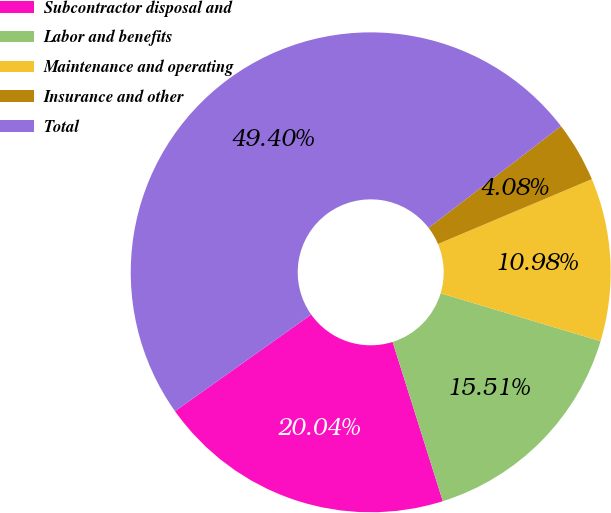Convert chart to OTSL. <chart><loc_0><loc_0><loc_500><loc_500><pie_chart><fcel>Subcontractor disposal and<fcel>Labor and benefits<fcel>Maintenance and operating<fcel>Insurance and other<fcel>Total<nl><fcel>20.04%<fcel>15.51%<fcel>10.98%<fcel>4.08%<fcel>49.4%<nl></chart> 